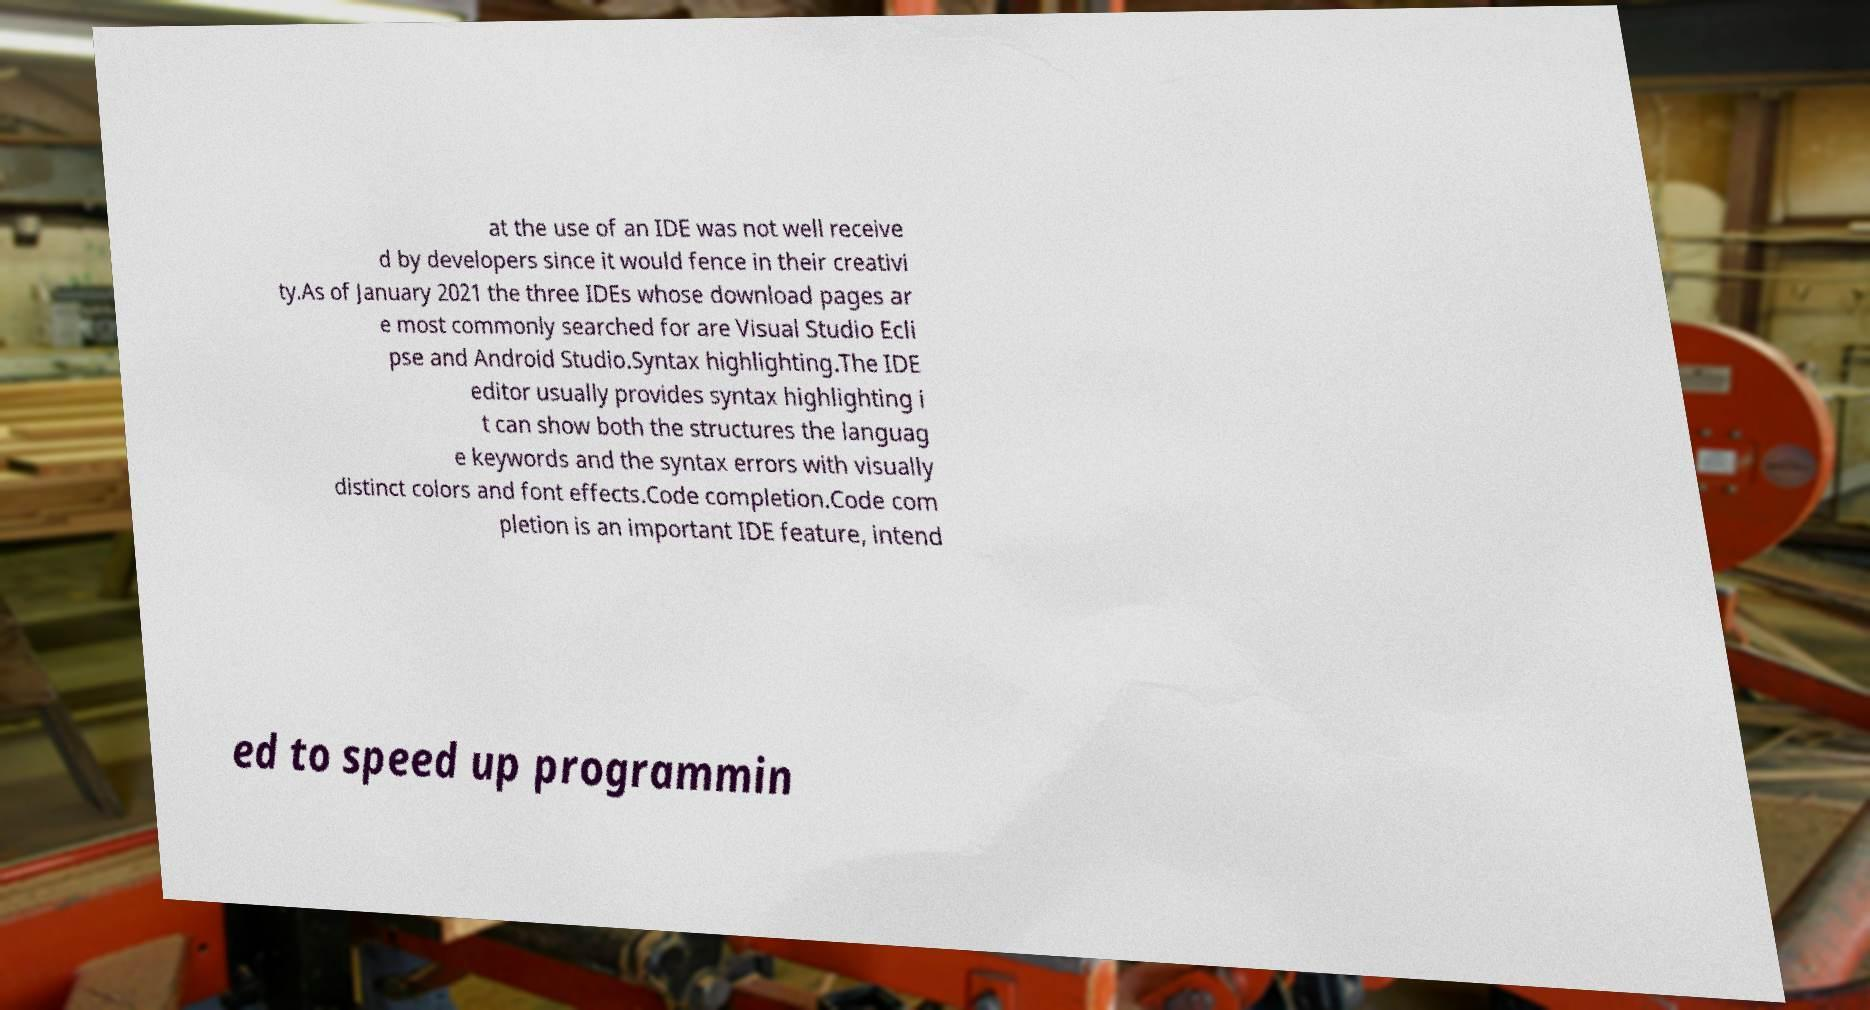For documentation purposes, I need the text within this image transcribed. Could you provide that? at the use of an IDE was not well receive d by developers since it would fence in their creativi ty.As of January 2021 the three IDEs whose download pages ar e most commonly searched for are Visual Studio Ecli pse and Android Studio.Syntax highlighting.The IDE editor usually provides syntax highlighting i t can show both the structures the languag e keywords and the syntax errors with visually distinct colors and font effects.Code completion.Code com pletion is an important IDE feature, intend ed to speed up programmin 